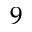<formula> <loc_0><loc_0><loc_500><loc_500>^ { 9 }</formula> 